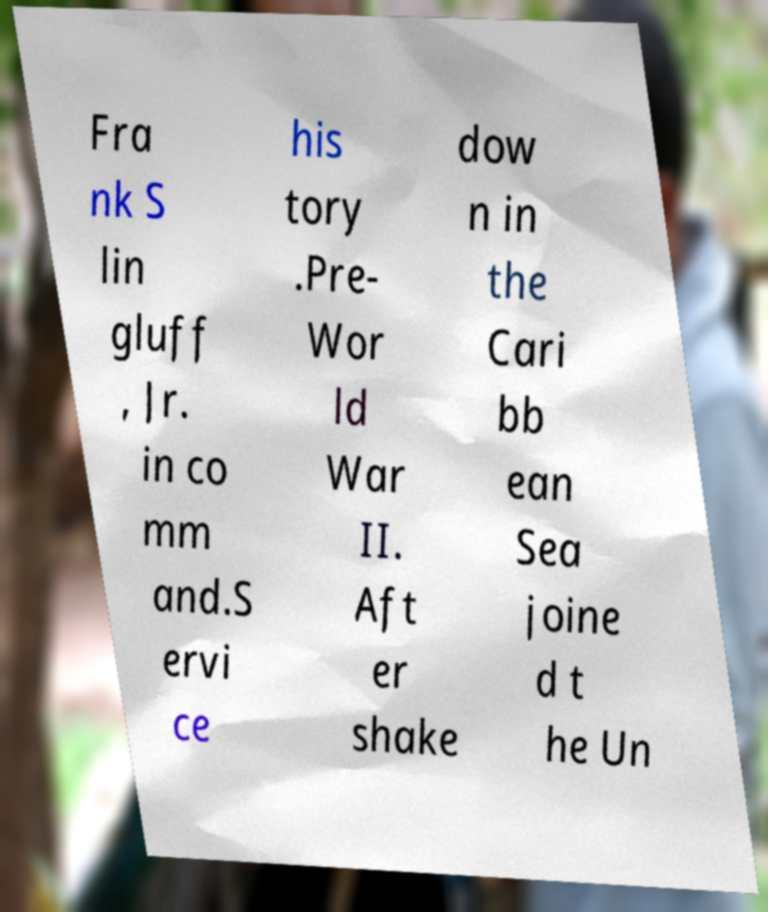Can you accurately transcribe the text from the provided image for me? Fra nk S lin gluff , Jr. in co mm and.S ervi ce his tory .Pre- Wor ld War II. Aft er shake dow n in the Cari bb ean Sea joine d t he Un 